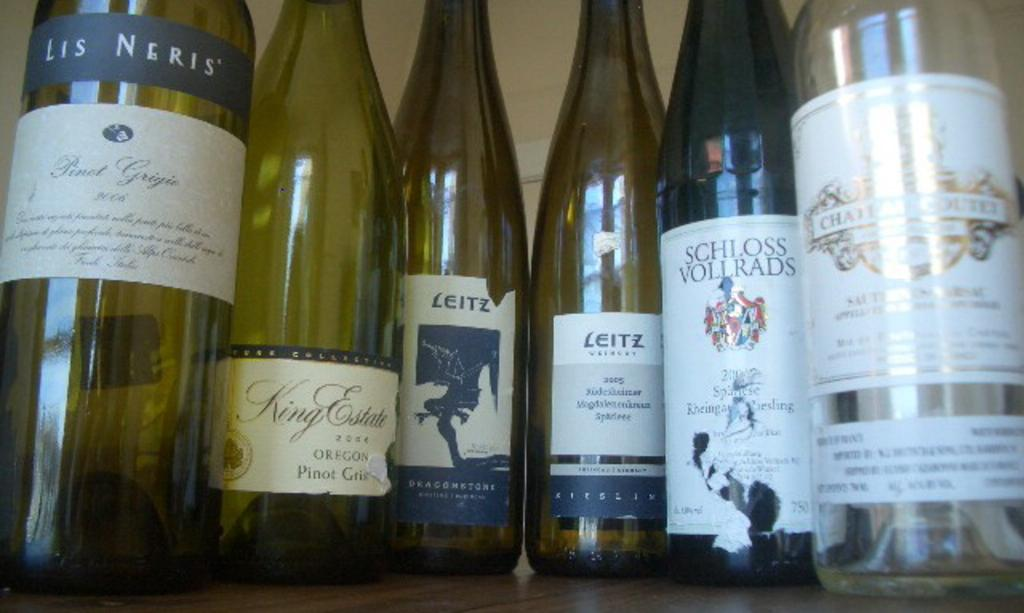<image>
Relay a brief, clear account of the picture shown. a group of wine bottles that include Schloss Volrads. 